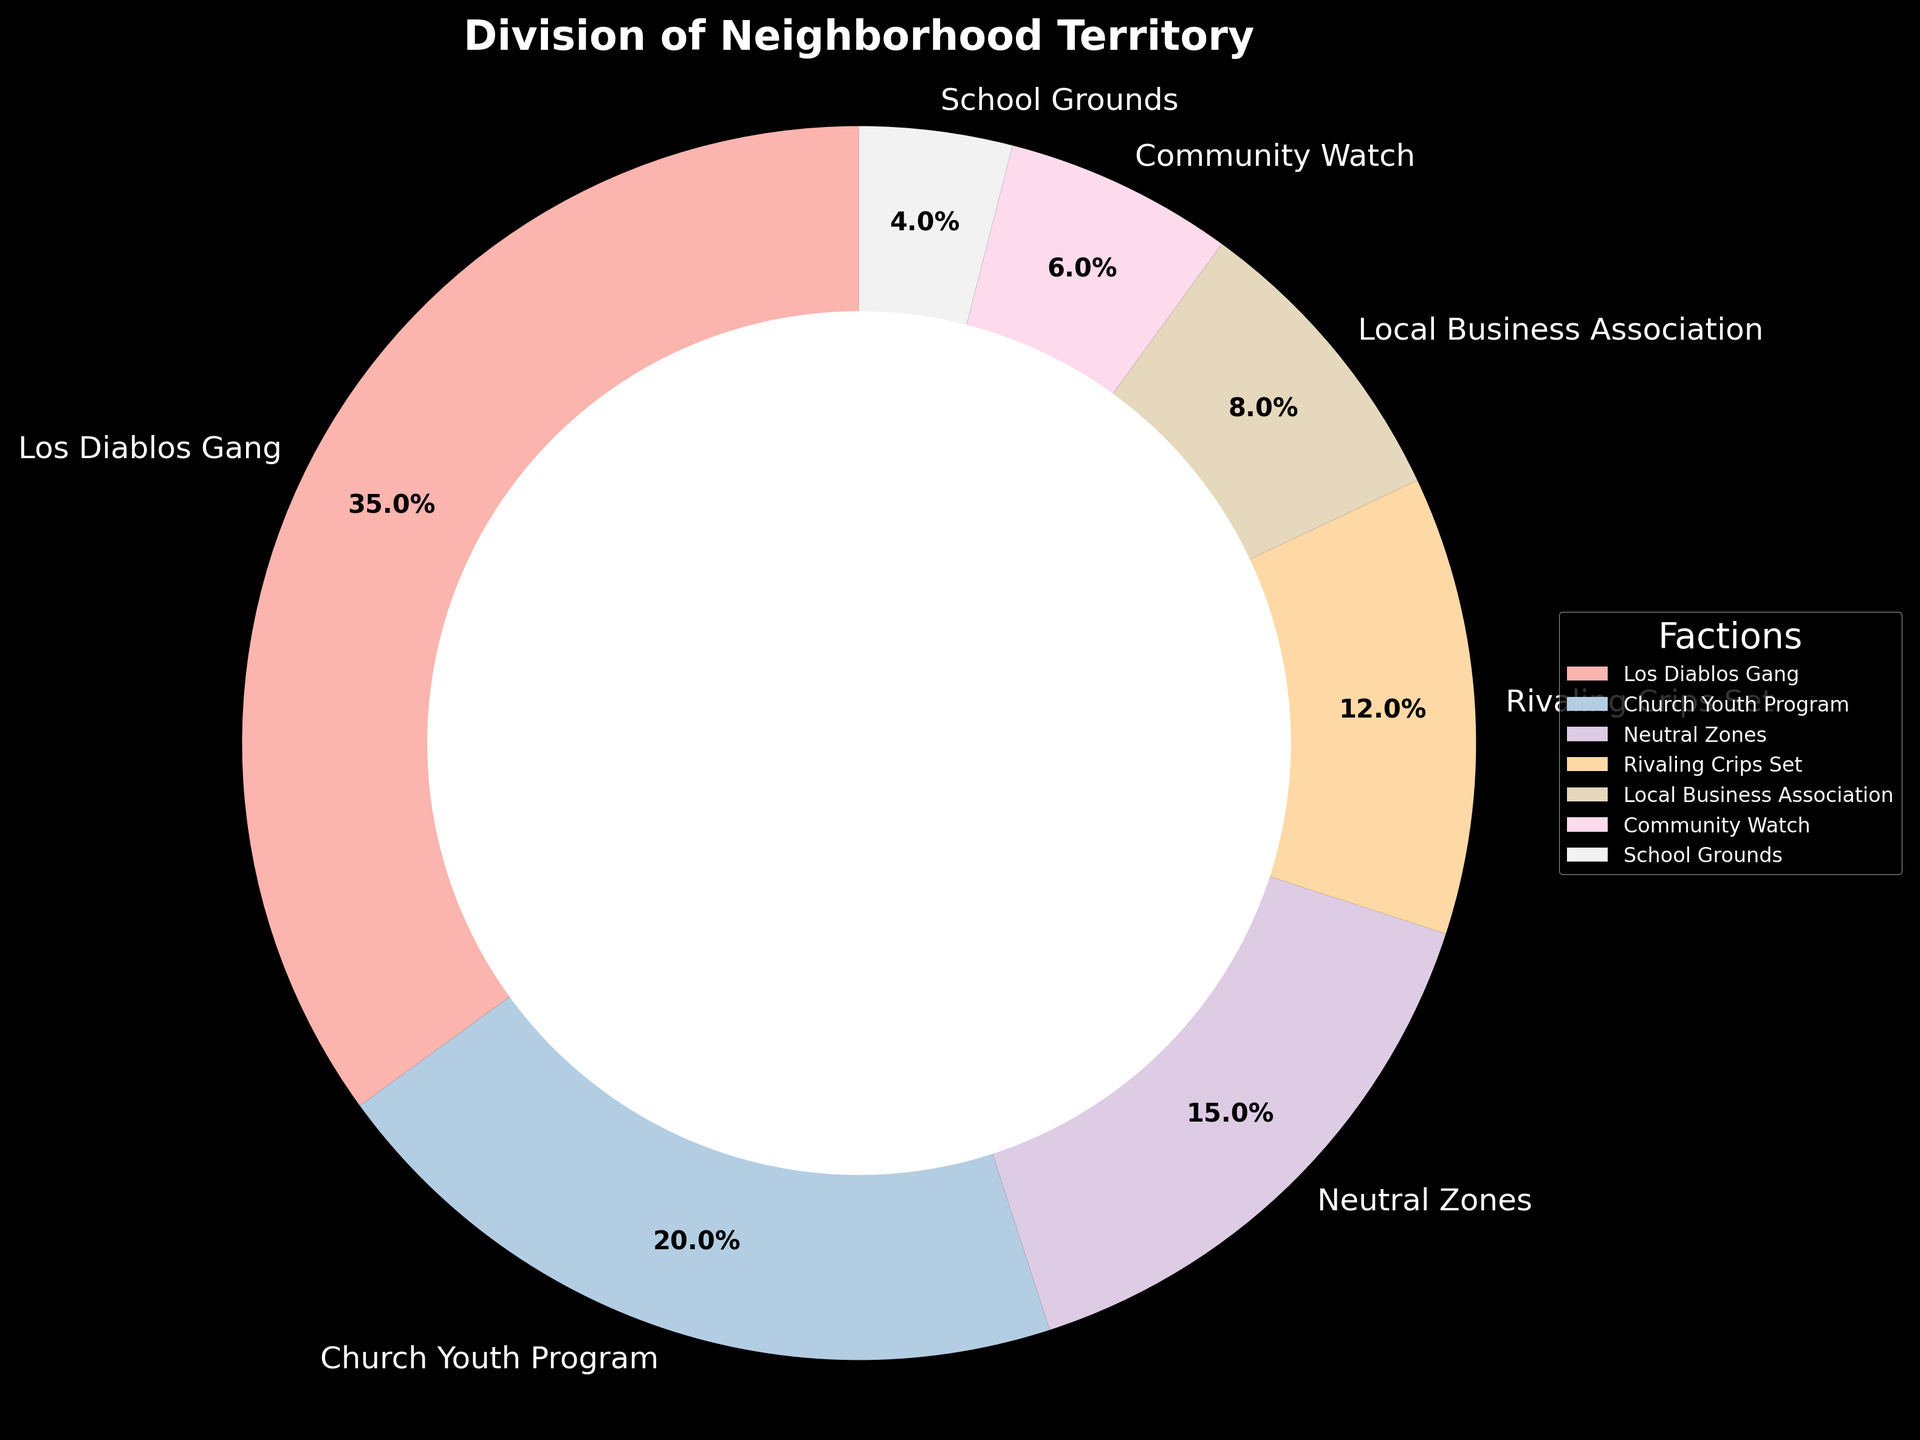What percentage of territory is held by the Los Diablos Gang? Look at the slice labeled "Los Diablos Gang" in the pie chart. The figure shows that this faction controls 35% of the territory.
Answer: 35% Which faction controls the smallest percentage of the neighborhood territory? Identify the smallest slice in the pie chart. The "School Grounds" faction appears to have the least territory with 4%.
Answer: School Grounds What is the combined territory percentage of the Los Diablos Gang and the Rivaling Crips Set? Add the percentages of the Los Diablos Gang (35%) and the Rivaling Crips Set (12%) to get the total. 35% + 12% = 47%.
Answer: 47% How much more territory does the Los Diablos Gang control compared to the Church Youth Program? Subtract the percentage of the Church Youth Program (20%) from the Los Diablos Gang's percentage (35%). 35% - 20% = 15%.
Answer: 15% Which factions hold equal or more than 10% of the territory? Observe each slice and its corresponding percentage. The Los Diablos Gang (35%), Church Youth Program (20%), and Rivaling Crips Set (12%) all hold equal or more than 10% each.
Answer: Los Diablos Gang, Church Youth Program, Rivaling Crips Set What is the total territory percentage controlled by Neutral Zones, Local Business Association, and Community Watch? Add the percentages of Neutral Zones (15%), Local Business Association (8%), and Community Watch (6%). 15% + 8% + 6% = 29%.
Answer: 29% How does the territory percentage of the Church Youth Program compare to the Local Business Association and Community Watch combined? First, sum the percentages of Local Business Association (8%) and Community Watch (6%) which equals 14%. The Church Youth Program controls 20%, which is higher.
Answer: Higher If the territory of the Church Youth Program increased by 5%, what would their new territory percentage be? Add 5% to the current percentage of the Church Youth Program (20%). 20% + 5% = 25%.
Answer: 25% Which factions together control exactly half of the neighborhood territory? Start by checking combination of factions' percentages that sum up to 50%. Los Diablos Gang (35%) and Church Youth Program (20%) together control 55%. However, Los Diablos Gang (35%) and Neutral Zones (15%) together control exactly 50%.
Answer: Los Diablos Gang, Neutral Zones 